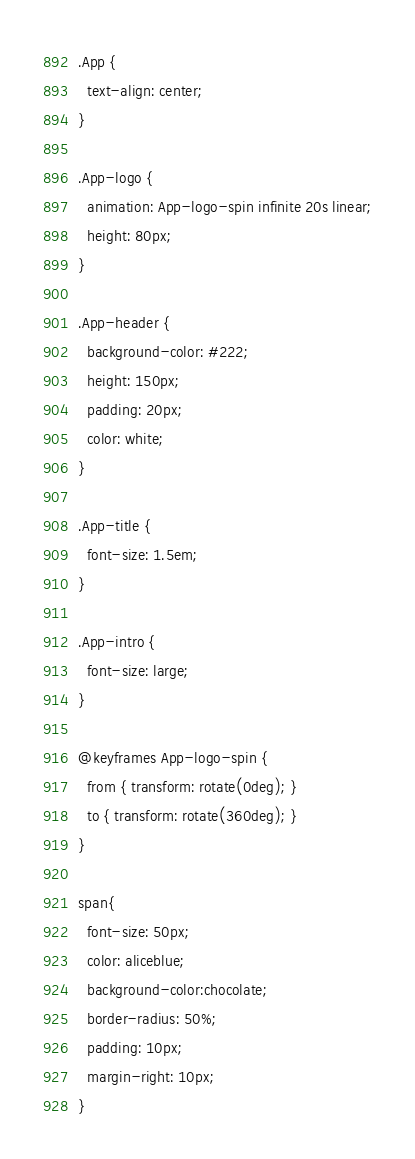<code> <loc_0><loc_0><loc_500><loc_500><_CSS_>.App {
  text-align: center;
}

.App-logo {
  animation: App-logo-spin infinite 20s linear;
  height: 80px;
}

.App-header {
  background-color: #222;
  height: 150px;
  padding: 20px;
  color: white;
}

.App-title {
  font-size: 1.5em;
}

.App-intro {
  font-size: large;
}

@keyframes App-logo-spin {
  from { transform: rotate(0deg); }
  to { transform: rotate(360deg); }
}

span{
  font-size: 50px;
  color: aliceblue;
  background-color:chocolate;
  border-radius: 50%;
  padding: 10px;
  margin-right: 10px;
}</code> 